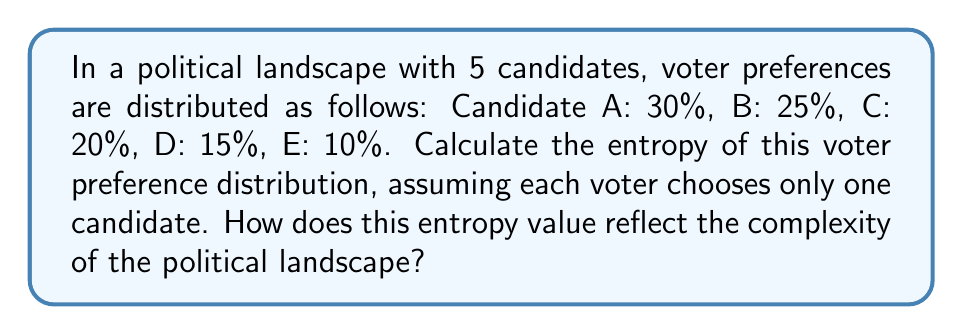Can you solve this math problem? To calculate the entropy of the voter preference distribution, we'll use the Shannon entropy formula:

$$S = -\sum_{i=1}^{n} p_i \log_2(p_i)$$

Where $S$ is the entropy, $p_i$ is the probability of each outcome, and $n$ is the number of possible outcomes.

Step 1: Convert percentages to probabilities
A: 0.30, B: 0.25, C: 0.20, D: 0.15, E: 0.10

Step 2: Calculate each term in the sum
$$\begin{align*}
-0.30 \log_2(0.30) &= 0.5211 \\
-0.25 \log_2(0.25) &= 0.5000 \\
-0.20 \log_2(0.20) &= 0.4644 \\
-0.15 \log_2(0.15) &= 0.4101 \\
-0.10 \log_2(0.10) &= 0.3322
\end{align*}$$

Step 3: Sum all terms
$$S = 0.5211 + 0.5000 + 0.4644 + 0.4101 + 0.3322 = 2.2278$$

The entropy value of 2.2278 bits reflects a moderately complex political landscape. The maximum possible entropy for a 5-candidate system would be $\log_2(5) \approx 2.3219$ bits, occurring when all candidates have equal support. Our calculated value is close to this maximum, indicating a diverse distribution of voter preferences without a single dominant candidate.
Answer: 2.2278 bits 